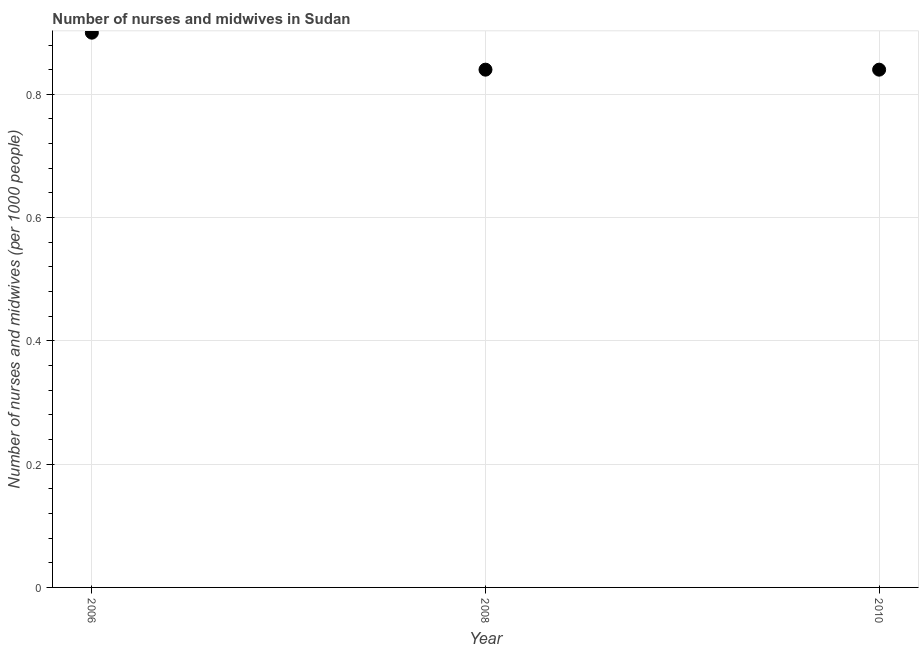Across all years, what is the minimum number of nurses and midwives?
Offer a terse response. 0.84. In which year was the number of nurses and midwives maximum?
Offer a terse response. 2006. In which year was the number of nurses and midwives minimum?
Provide a succinct answer. 2008. What is the sum of the number of nurses and midwives?
Provide a short and direct response. 2.58. What is the average number of nurses and midwives per year?
Your response must be concise. 0.86. What is the median number of nurses and midwives?
Your answer should be very brief. 0.84. In how many years, is the number of nurses and midwives greater than 0.08 ?
Offer a very short reply. 3. Is the number of nurses and midwives in 2006 less than that in 2008?
Provide a succinct answer. No. Is the difference between the number of nurses and midwives in 2008 and 2010 greater than the difference between any two years?
Offer a terse response. No. What is the difference between the highest and the second highest number of nurses and midwives?
Make the answer very short. 0.06. Is the sum of the number of nurses and midwives in 2006 and 2008 greater than the maximum number of nurses and midwives across all years?
Provide a succinct answer. Yes. What is the difference between the highest and the lowest number of nurses and midwives?
Your response must be concise. 0.06. Does the number of nurses and midwives monotonically increase over the years?
Ensure brevity in your answer.  No. How many dotlines are there?
Your response must be concise. 1. What is the difference between two consecutive major ticks on the Y-axis?
Provide a short and direct response. 0.2. Are the values on the major ticks of Y-axis written in scientific E-notation?
Your response must be concise. No. What is the title of the graph?
Make the answer very short. Number of nurses and midwives in Sudan. What is the label or title of the Y-axis?
Offer a very short reply. Number of nurses and midwives (per 1000 people). What is the Number of nurses and midwives (per 1000 people) in 2006?
Your response must be concise. 0.9. What is the Number of nurses and midwives (per 1000 people) in 2008?
Provide a succinct answer. 0.84. What is the Number of nurses and midwives (per 1000 people) in 2010?
Offer a very short reply. 0.84. What is the difference between the Number of nurses and midwives (per 1000 people) in 2006 and 2008?
Provide a succinct answer. 0.06. What is the difference between the Number of nurses and midwives (per 1000 people) in 2008 and 2010?
Provide a succinct answer. 0. What is the ratio of the Number of nurses and midwives (per 1000 people) in 2006 to that in 2008?
Your answer should be compact. 1.07. What is the ratio of the Number of nurses and midwives (per 1000 people) in 2006 to that in 2010?
Your answer should be compact. 1.07. What is the ratio of the Number of nurses and midwives (per 1000 people) in 2008 to that in 2010?
Provide a succinct answer. 1. 